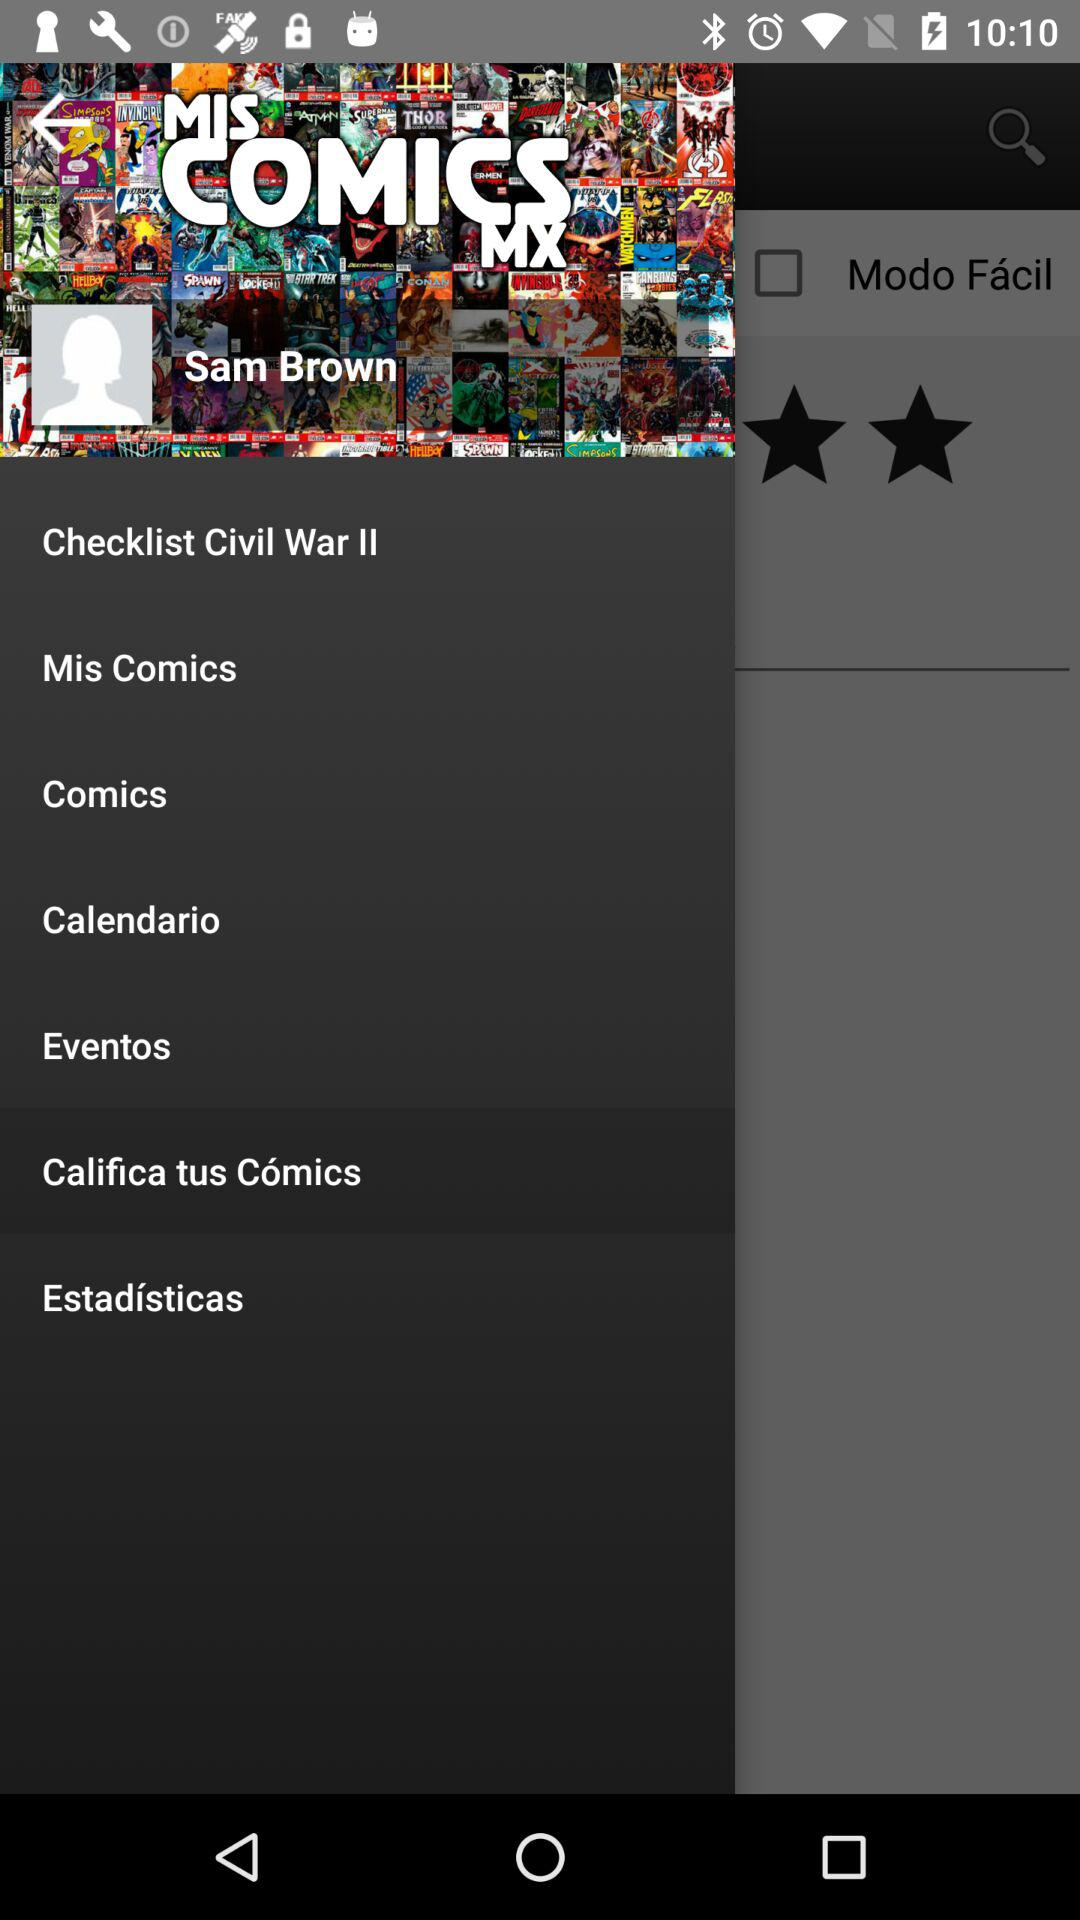Which option is selected? The selected option is "Califica tus Cómics". 